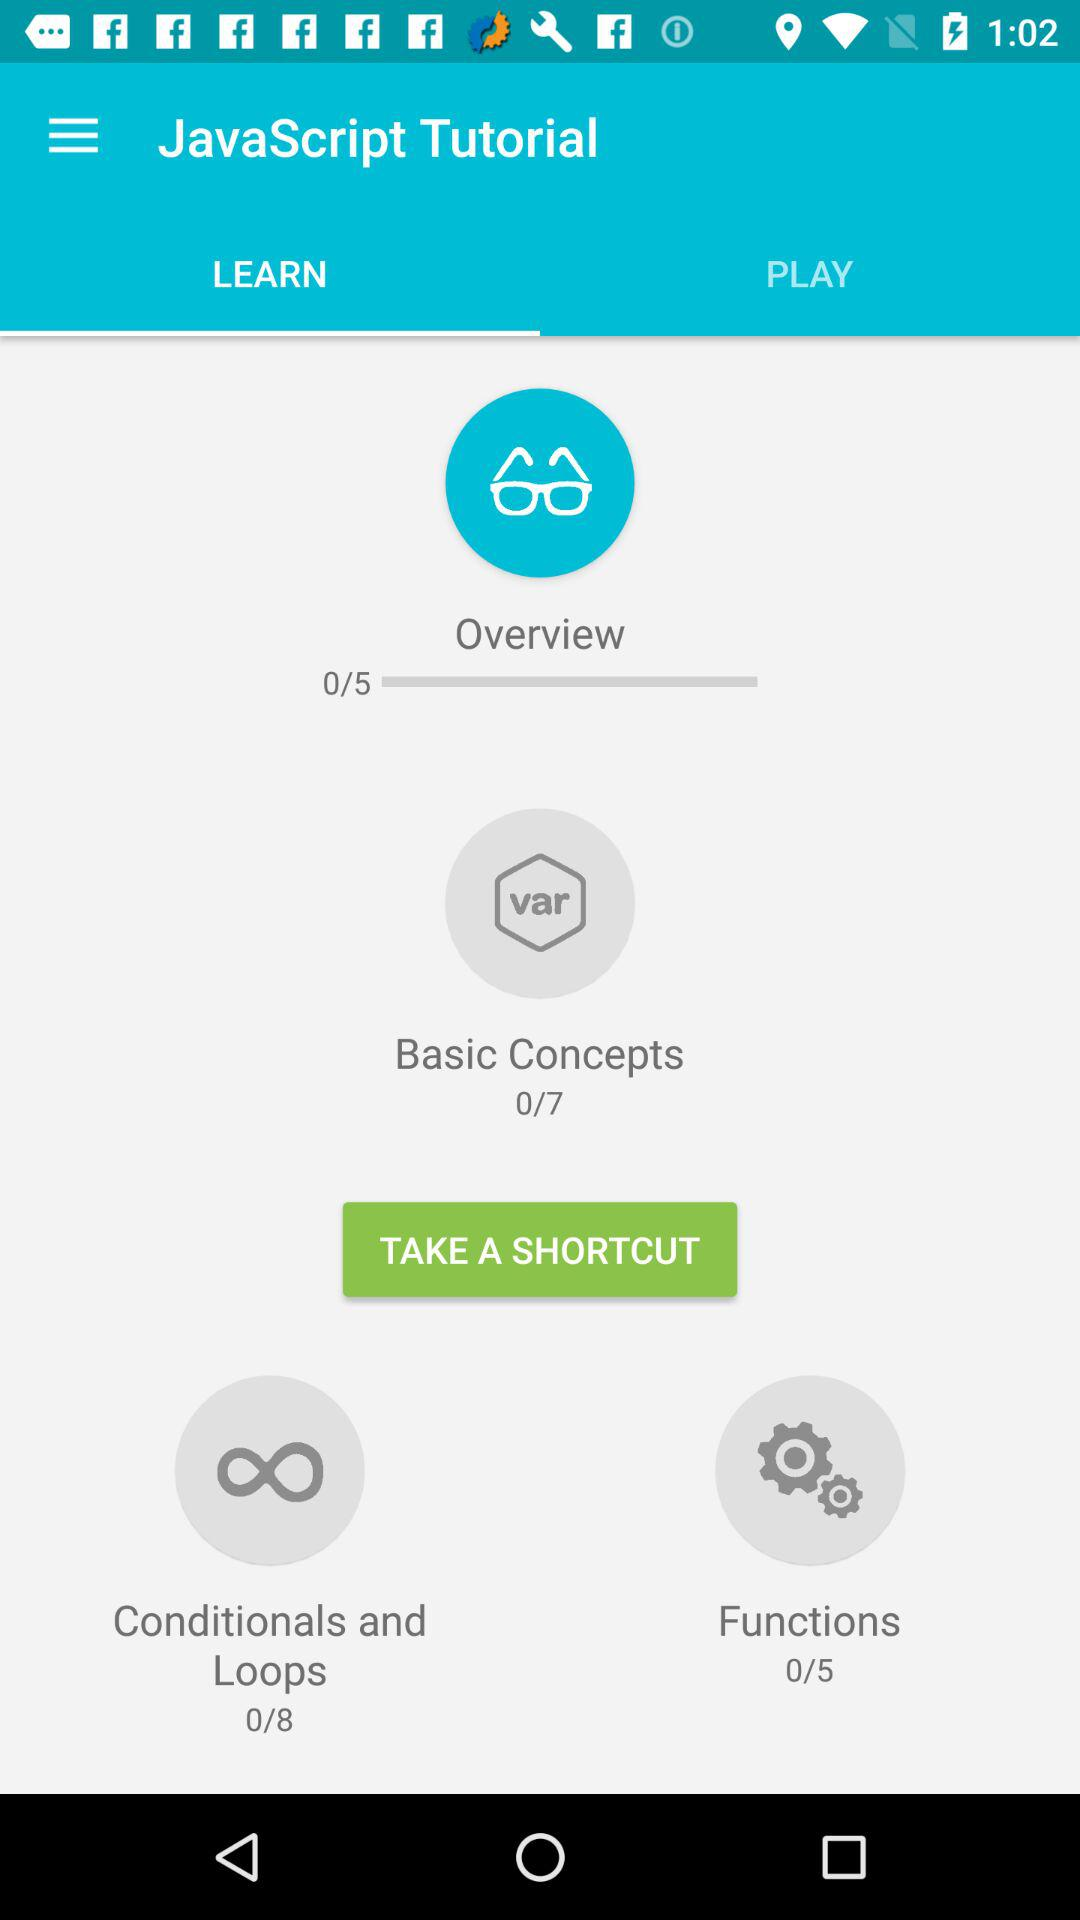How many more lessons are there in the Conditionals and Loops section than the Functions section?
Answer the question using a single word or phrase. 3 